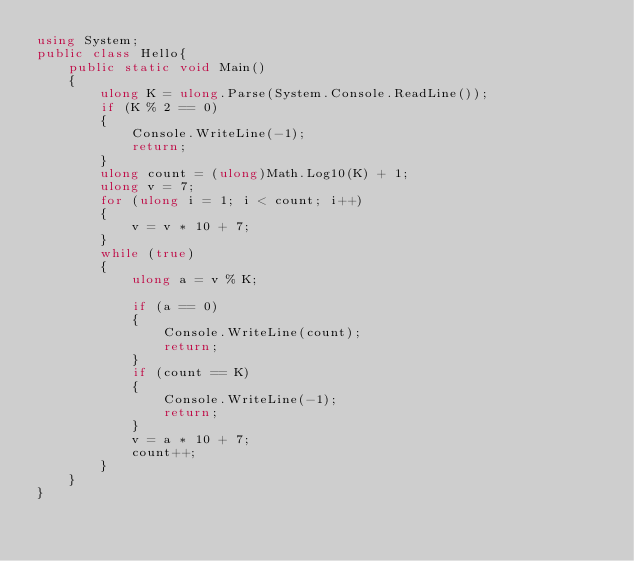<code> <loc_0><loc_0><loc_500><loc_500><_C#_>using System;
public class Hello{
    public static void Main()
    {
        ulong K = ulong.Parse(System.Console.ReadLine());
        if (K % 2 == 0)
        {
            Console.WriteLine(-1);
            return;
        }
        ulong count = (ulong)Math.Log10(K) + 1;
        ulong v = 7; 
        for (ulong i = 1; i < count; i++)
        {
            v = v * 10 + 7;
        }
        while (true)
        {
            ulong a = v % K;

            if (a == 0)
            {
                Console.WriteLine(count);
                return;
            }
            if (count == K)
            {
                Console.WriteLine(-1);
                return;
            }            
            v = a * 10 + 7;
            count++;
        }
    }
}</code> 